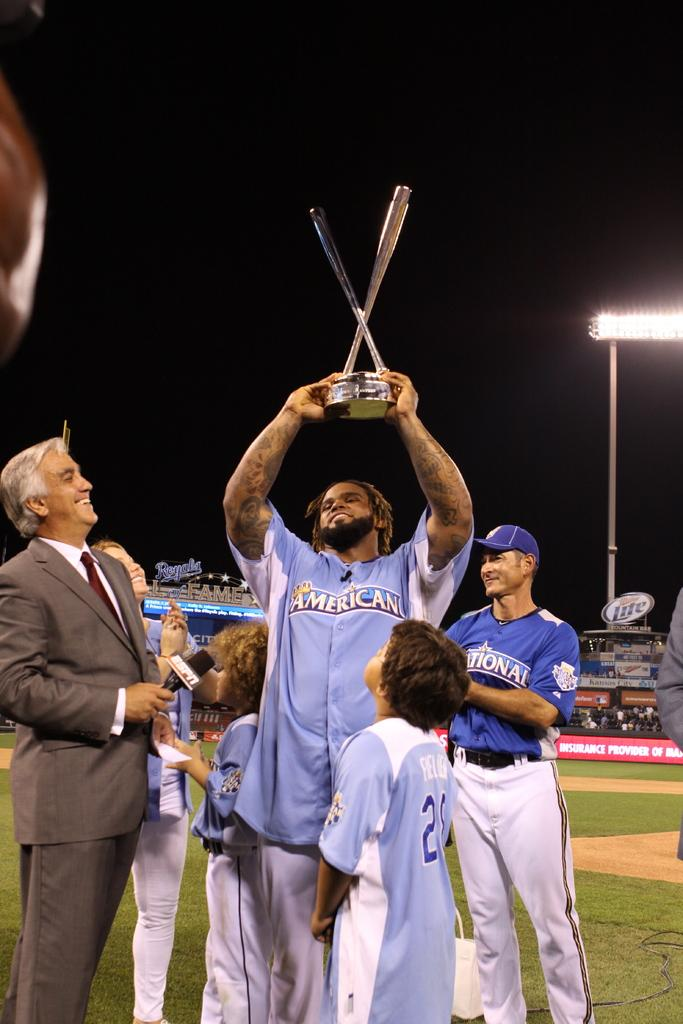<image>
Describe the image concisely. A man in an American shirt is holding up a trophy. 